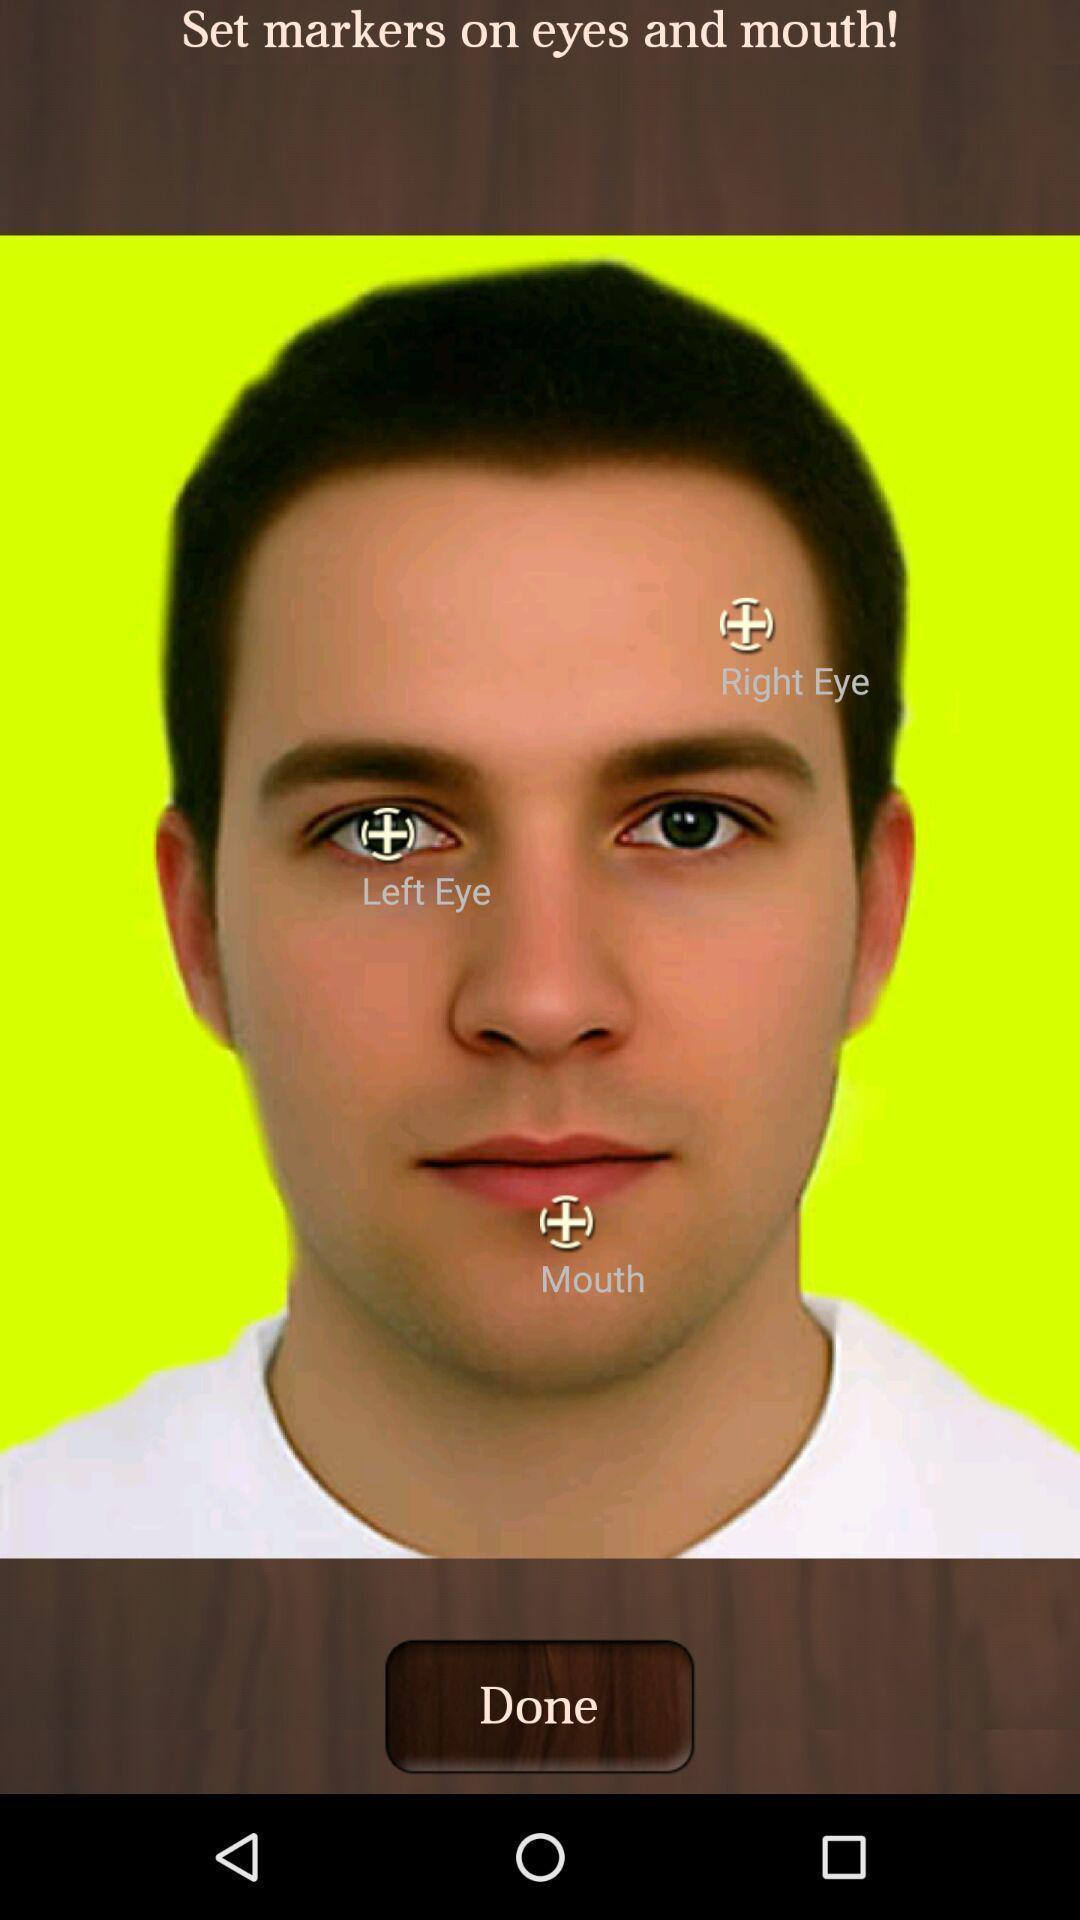Give me a summary of this screen capture. Screen shows a picture to edit. 